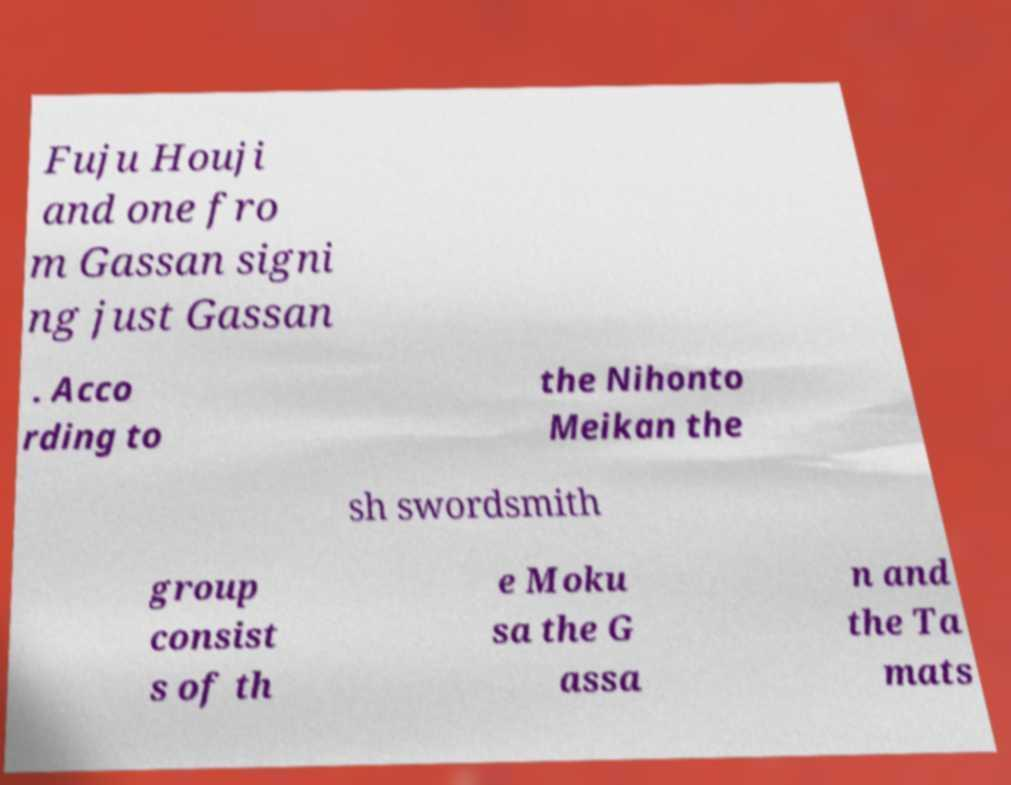Could you assist in decoding the text presented in this image and type it out clearly? Fuju Houji and one fro m Gassan signi ng just Gassan . Acco rding to the Nihonto Meikan the sh swordsmith group consist s of th e Moku sa the G assa n and the Ta mats 